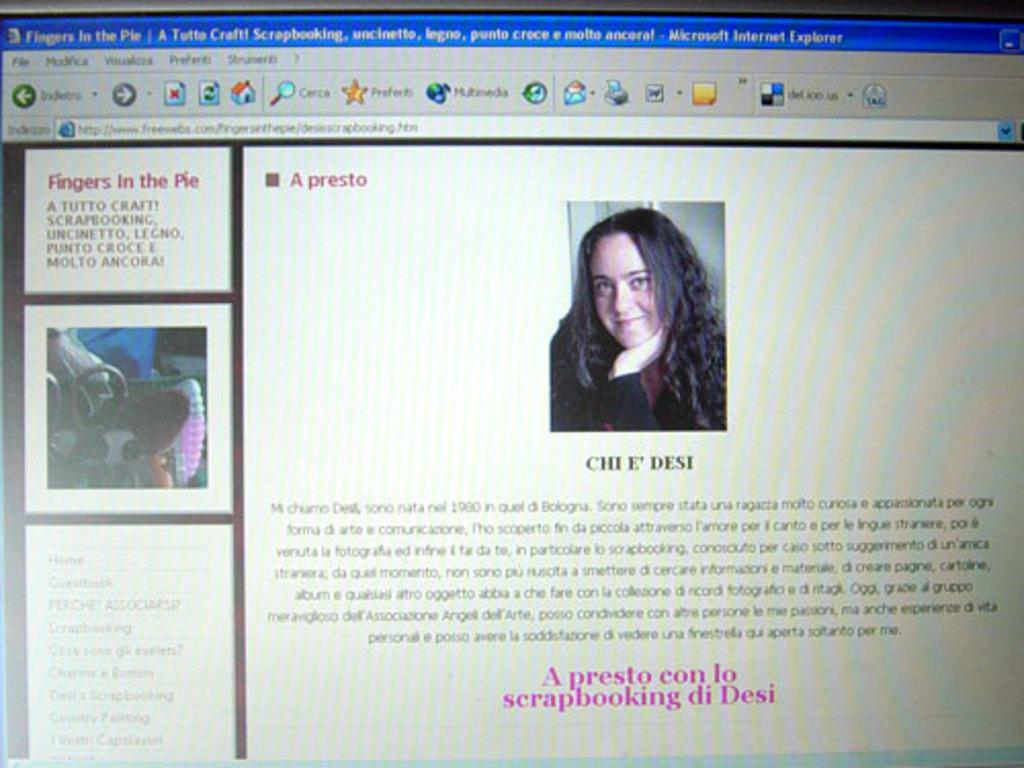What type of content is displayed on the web page in the image? The web page contains pictures and text. Can you describe the layout of the web page? The web page has an address bar and a toolbar at the top. What is the purpose of the address bar in the image? The address bar is used to display the web page's URL. What is the purpose of the toolbar in the image? The toolbar is used to provide access to various functions and tools related to the web browser. What type of hands can be seen interacting with the web page in the image? There are no hands visible in the image; it is a screenshot of a web page. Can you describe the tank that is present in the web page's content? There is no tank present in the web page's content; the image only contains pictures and text. 